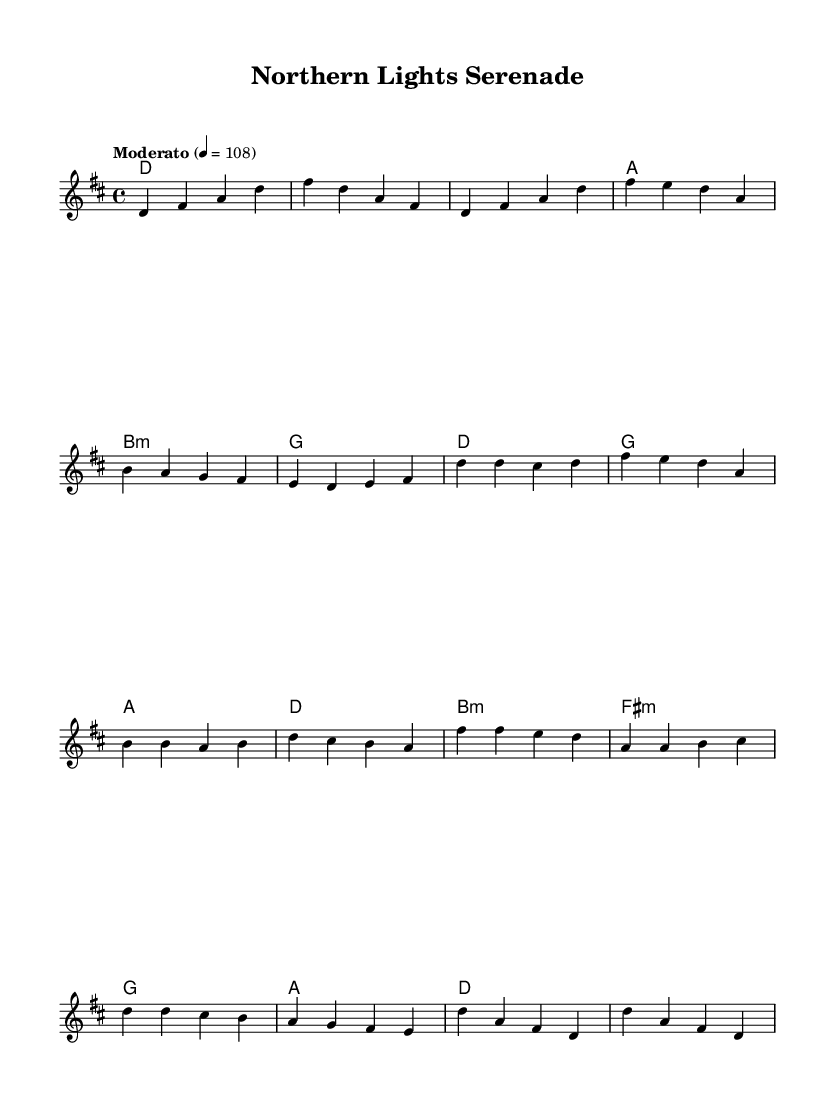What is the key signature of this music? The key signature is indicated at the beginning of the sheet music, showing two sharps. This corresponds to the key of D major.
Answer: D major What is the time signature of this music? The time signature is shown at the beginning of the score as 4/4, which means there are four beats in each measure.
Answer: 4/4 What is the tempo marking of this piece? The tempo marking indicates how fast or slow the piece should be played. It states "Moderato" and 4 = 108, meaning moderate speed at 108 beats per minute.
Answer: Moderato How many measures are in the chorus section? By counting the measures that comprise the chorus section outlined in the melody, we find there are four measures.
Answer: 4 Which chord is used in the bridge section? The bridge section starts with a B minor chord, as indicated in the harmonies.
Answer: B minor What is the last chord of the piece? The last chord in the score is a D major chord as indicated in the outro section of the harmonies.
Answer: D major What is a notable theme of the lyrics that could be inferred from the title? The title "Northern Lights Serenade" suggests themes related to nature and Inuit culture, possibly referencing the Aurora Borealis.
Answer: Nature 